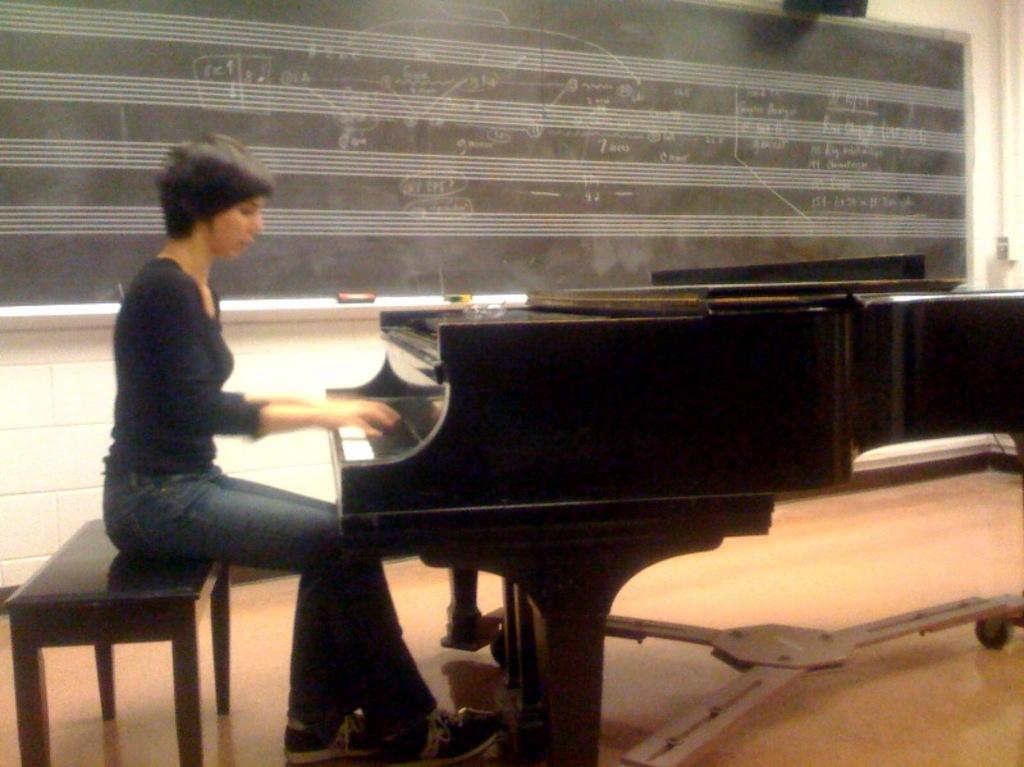What is the woman in the image doing? The woman is sitting on a bench in the image. What can be seen on the left side of the image? There is a piano table on the left side of the image. What is present in the background of the image? There is a black color board and a wall in the background of the image. How many trees can be seen near the stream in the image? There is no stream or trees present in the image. 